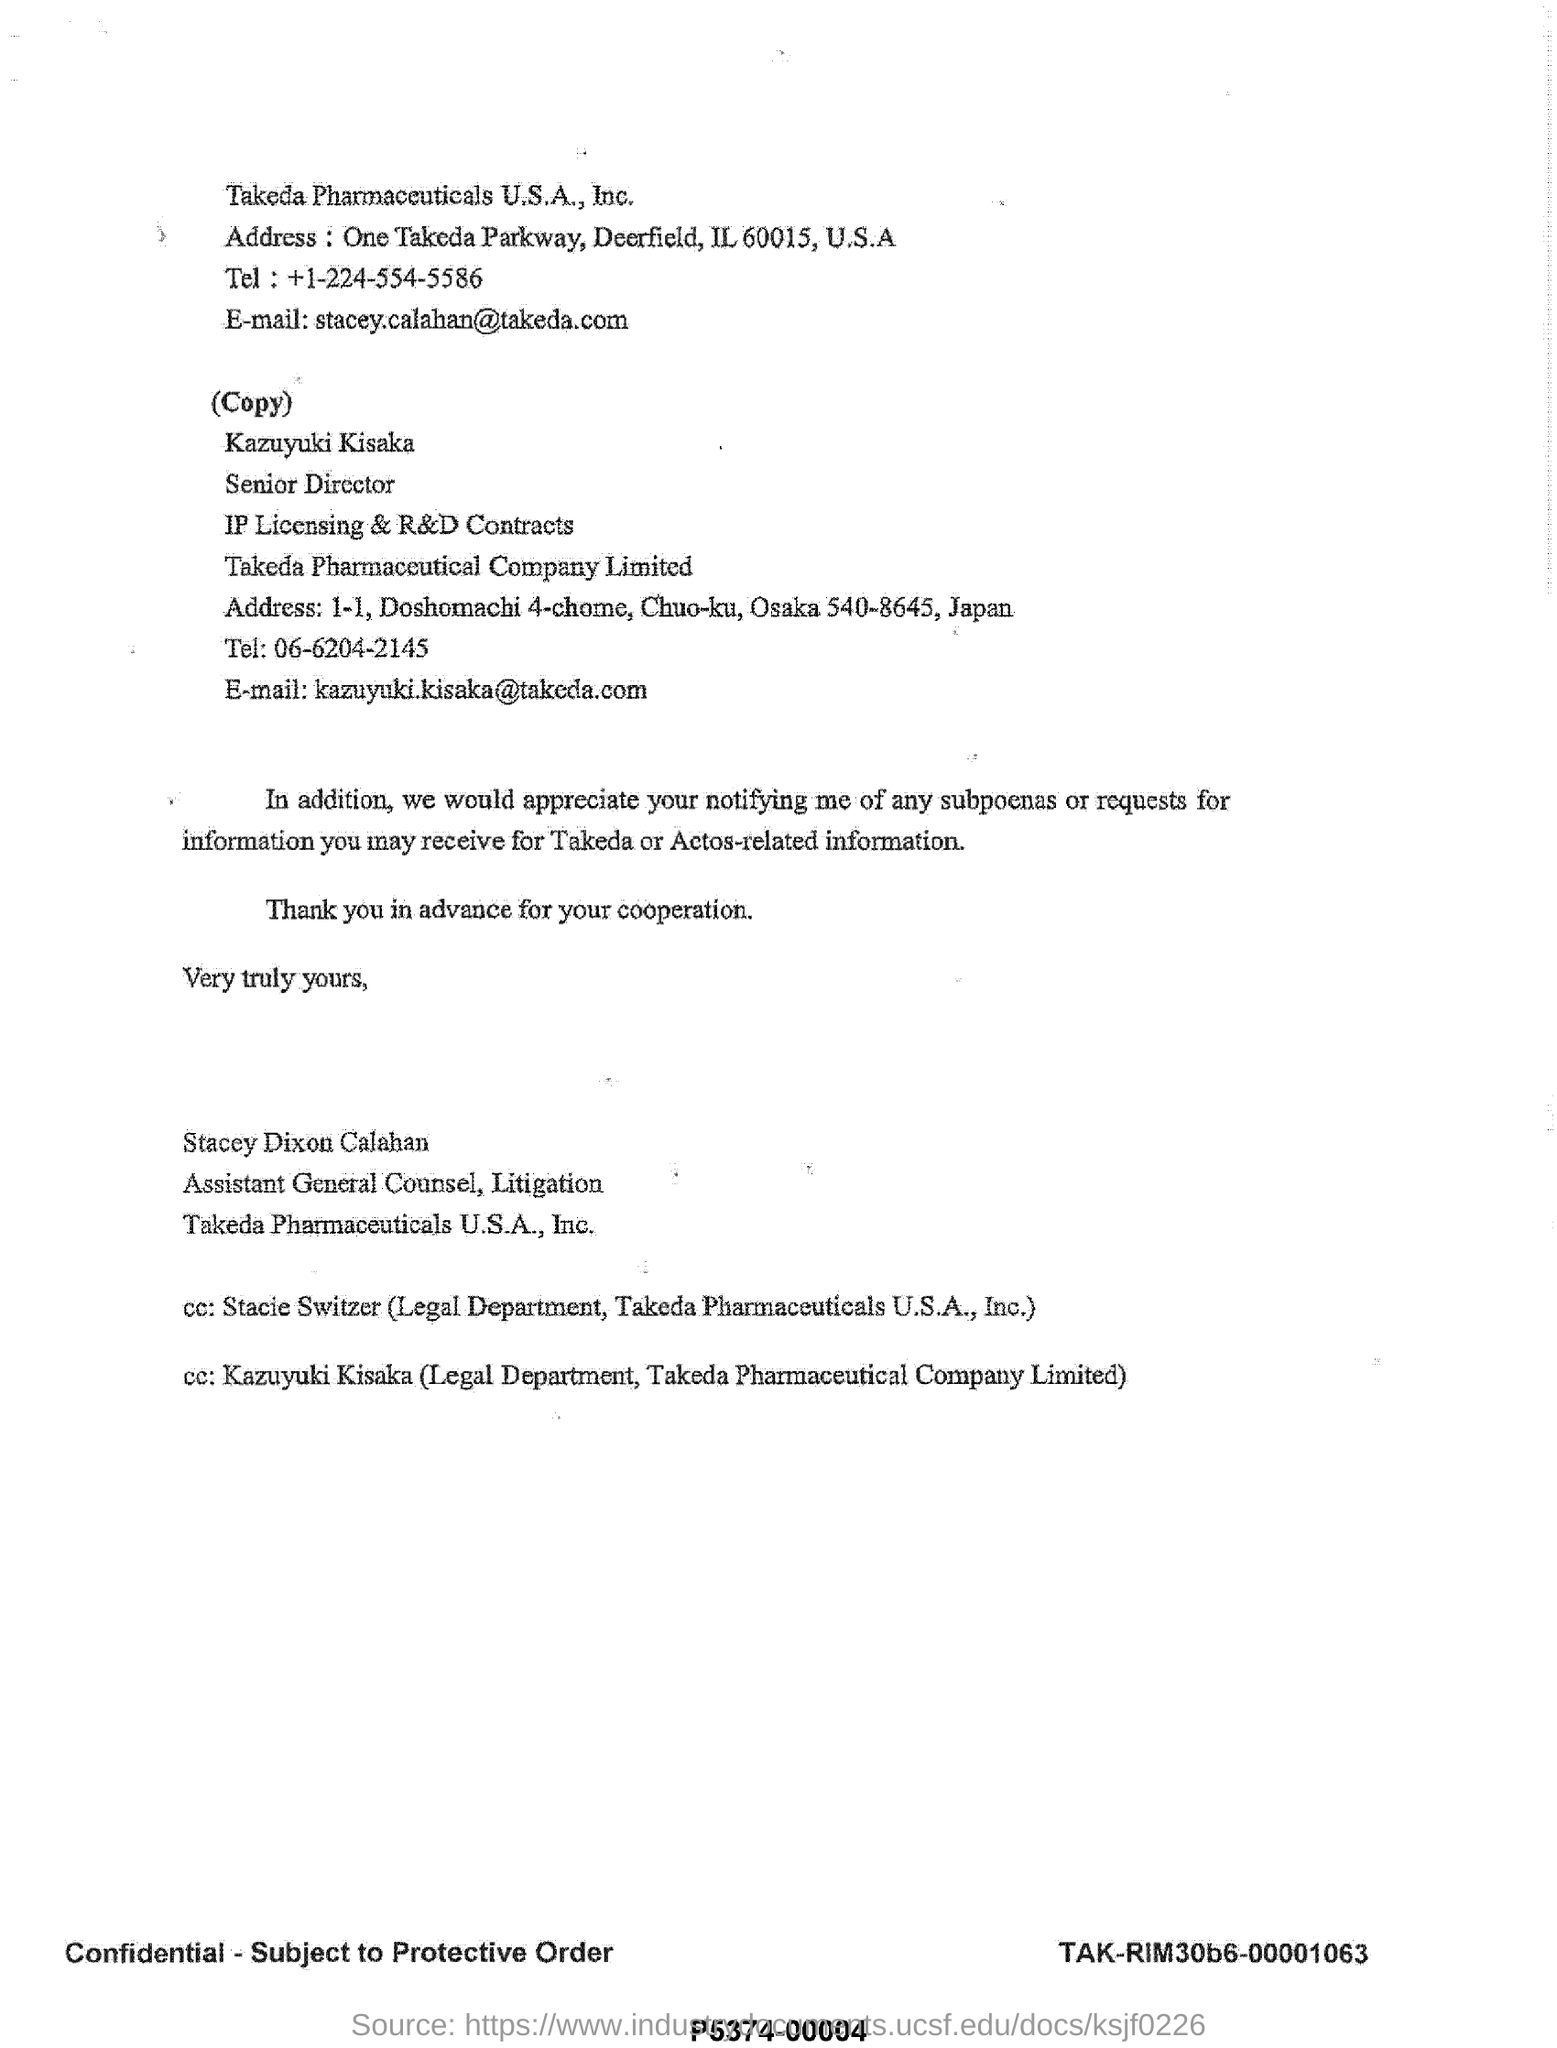Point out several critical features in this image. This document was written by Stacey Dixon Calahan. 